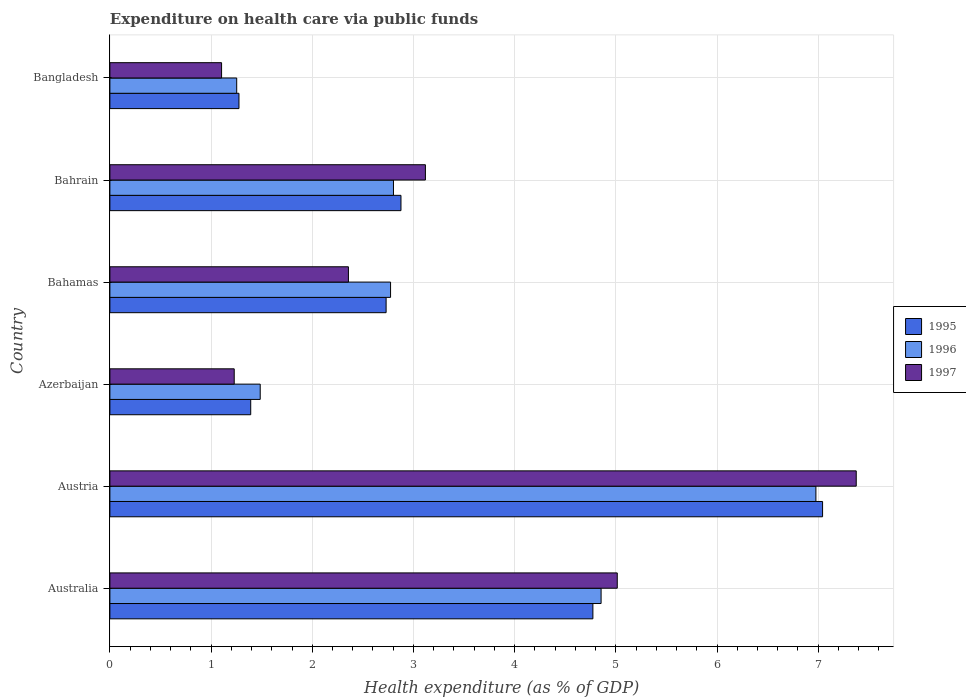How many different coloured bars are there?
Make the answer very short. 3. How many groups of bars are there?
Provide a succinct answer. 6. What is the label of the 1st group of bars from the top?
Provide a short and direct response. Bangladesh. What is the expenditure made on health care in 1995 in Azerbaijan?
Provide a succinct answer. 1.39. Across all countries, what is the maximum expenditure made on health care in 1997?
Make the answer very short. 7.38. Across all countries, what is the minimum expenditure made on health care in 1995?
Provide a short and direct response. 1.28. In which country was the expenditure made on health care in 1996 maximum?
Ensure brevity in your answer.  Austria. In which country was the expenditure made on health care in 1995 minimum?
Provide a succinct answer. Bangladesh. What is the total expenditure made on health care in 1997 in the graph?
Provide a succinct answer. 20.2. What is the difference between the expenditure made on health care in 1995 in Australia and that in Bahamas?
Your answer should be compact. 2.04. What is the difference between the expenditure made on health care in 1996 in Azerbaijan and the expenditure made on health care in 1995 in Australia?
Offer a very short reply. -3.29. What is the average expenditure made on health care in 1995 per country?
Offer a very short reply. 3.35. What is the difference between the expenditure made on health care in 1995 and expenditure made on health care in 1996 in Bahamas?
Make the answer very short. -0.04. In how many countries, is the expenditure made on health care in 1996 greater than 6 %?
Give a very brief answer. 1. What is the ratio of the expenditure made on health care in 1996 in Australia to that in Bangladesh?
Your response must be concise. 3.87. Is the expenditure made on health care in 1996 in Austria less than that in Bahrain?
Offer a very short reply. No. What is the difference between the highest and the second highest expenditure made on health care in 1997?
Your response must be concise. 2.36. What is the difference between the highest and the lowest expenditure made on health care in 1996?
Give a very brief answer. 5.72. In how many countries, is the expenditure made on health care in 1997 greater than the average expenditure made on health care in 1997 taken over all countries?
Your response must be concise. 2. How many bars are there?
Offer a terse response. 18. How many countries are there in the graph?
Offer a terse response. 6. What is the difference between two consecutive major ticks on the X-axis?
Keep it short and to the point. 1. Does the graph contain grids?
Offer a very short reply. Yes. Where does the legend appear in the graph?
Keep it short and to the point. Center right. What is the title of the graph?
Your answer should be very brief. Expenditure on health care via public funds. Does "1978" appear as one of the legend labels in the graph?
Offer a very short reply. No. What is the label or title of the X-axis?
Your answer should be very brief. Health expenditure (as % of GDP). What is the Health expenditure (as % of GDP) of 1995 in Australia?
Make the answer very short. 4.77. What is the Health expenditure (as % of GDP) in 1996 in Australia?
Your answer should be compact. 4.85. What is the Health expenditure (as % of GDP) in 1997 in Australia?
Your response must be concise. 5.01. What is the Health expenditure (as % of GDP) of 1995 in Austria?
Provide a short and direct response. 7.04. What is the Health expenditure (as % of GDP) in 1996 in Austria?
Offer a terse response. 6.98. What is the Health expenditure (as % of GDP) in 1997 in Austria?
Your answer should be very brief. 7.38. What is the Health expenditure (as % of GDP) in 1995 in Azerbaijan?
Your answer should be very brief. 1.39. What is the Health expenditure (as % of GDP) of 1996 in Azerbaijan?
Make the answer very short. 1.49. What is the Health expenditure (as % of GDP) of 1997 in Azerbaijan?
Your answer should be compact. 1.23. What is the Health expenditure (as % of GDP) in 1995 in Bahamas?
Offer a very short reply. 2.73. What is the Health expenditure (as % of GDP) in 1996 in Bahamas?
Keep it short and to the point. 2.77. What is the Health expenditure (as % of GDP) of 1997 in Bahamas?
Ensure brevity in your answer.  2.36. What is the Health expenditure (as % of GDP) of 1995 in Bahrain?
Your answer should be compact. 2.88. What is the Health expenditure (as % of GDP) of 1996 in Bahrain?
Ensure brevity in your answer.  2.8. What is the Health expenditure (as % of GDP) in 1997 in Bahrain?
Your answer should be compact. 3.12. What is the Health expenditure (as % of GDP) of 1995 in Bangladesh?
Give a very brief answer. 1.28. What is the Health expenditure (as % of GDP) of 1996 in Bangladesh?
Give a very brief answer. 1.25. What is the Health expenditure (as % of GDP) in 1997 in Bangladesh?
Offer a very short reply. 1.1. Across all countries, what is the maximum Health expenditure (as % of GDP) of 1995?
Provide a succinct answer. 7.04. Across all countries, what is the maximum Health expenditure (as % of GDP) in 1996?
Your answer should be compact. 6.98. Across all countries, what is the maximum Health expenditure (as % of GDP) in 1997?
Keep it short and to the point. 7.38. Across all countries, what is the minimum Health expenditure (as % of GDP) of 1995?
Offer a terse response. 1.28. Across all countries, what is the minimum Health expenditure (as % of GDP) of 1996?
Your response must be concise. 1.25. Across all countries, what is the minimum Health expenditure (as % of GDP) in 1997?
Ensure brevity in your answer.  1.1. What is the total Health expenditure (as % of GDP) of 1995 in the graph?
Your answer should be very brief. 20.09. What is the total Health expenditure (as % of GDP) in 1996 in the graph?
Provide a short and direct response. 20.15. What is the total Health expenditure (as % of GDP) in 1997 in the graph?
Offer a very short reply. 20.2. What is the difference between the Health expenditure (as % of GDP) in 1995 in Australia and that in Austria?
Make the answer very short. -2.27. What is the difference between the Health expenditure (as % of GDP) in 1996 in Australia and that in Austria?
Ensure brevity in your answer.  -2.12. What is the difference between the Health expenditure (as % of GDP) of 1997 in Australia and that in Austria?
Your response must be concise. -2.36. What is the difference between the Health expenditure (as % of GDP) of 1995 in Australia and that in Azerbaijan?
Provide a short and direct response. 3.38. What is the difference between the Health expenditure (as % of GDP) of 1996 in Australia and that in Azerbaijan?
Your answer should be compact. 3.37. What is the difference between the Health expenditure (as % of GDP) of 1997 in Australia and that in Azerbaijan?
Keep it short and to the point. 3.79. What is the difference between the Health expenditure (as % of GDP) of 1995 in Australia and that in Bahamas?
Give a very brief answer. 2.04. What is the difference between the Health expenditure (as % of GDP) in 1996 in Australia and that in Bahamas?
Your answer should be compact. 2.08. What is the difference between the Health expenditure (as % of GDP) of 1997 in Australia and that in Bahamas?
Provide a succinct answer. 2.66. What is the difference between the Health expenditure (as % of GDP) of 1995 in Australia and that in Bahrain?
Your answer should be compact. 1.9. What is the difference between the Health expenditure (as % of GDP) of 1996 in Australia and that in Bahrain?
Offer a very short reply. 2.05. What is the difference between the Health expenditure (as % of GDP) in 1997 in Australia and that in Bahrain?
Offer a very short reply. 1.9. What is the difference between the Health expenditure (as % of GDP) of 1995 in Australia and that in Bangladesh?
Offer a terse response. 3.5. What is the difference between the Health expenditure (as % of GDP) of 1996 in Australia and that in Bangladesh?
Offer a terse response. 3.6. What is the difference between the Health expenditure (as % of GDP) in 1997 in Australia and that in Bangladesh?
Your answer should be very brief. 3.91. What is the difference between the Health expenditure (as % of GDP) in 1995 in Austria and that in Azerbaijan?
Make the answer very short. 5.65. What is the difference between the Health expenditure (as % of GDP) in 1996 in Austria and that in Azerbaijan?
Your answer should be compact. 5.49. What is the difference between the Health expenditure (as % of GDP) in 1997 in Austria and that in Azerbaijan?
Offer a terse response. 6.15. What is the difference between the Health expenditure (as % of GDP) in 1995 in Austria and that in Bahamas?
Your response must be concise. 4.31. What is the difference between the Health expenditure (as % of GDP) of 1996 in Austria and that in Bahamas?
Provide a short and direct response. 4.2. What is the difference between the Health expenditure (as % of GDP) of 1997 in Austria and that in Bahamas?
Make the answer very short. 5.02. What is the difference between the Health expenditure (as % of GDP) of 1995 in Austria and that in Bahrain?
Your answer should be very brief. 4.17. What is the difference between the Health expenditure (as % of GDP) of 1996 in Austria and that in Bahrain?
Keep it short and to the point. 4.17. What is the difference between the Health expenditure (as % of GDP) in 1997 in Austria and that in Bahrain?
Your answer should be compact. 4.26. What is the difference between the Health expenditure (as % of GDP) in 1995 in Austria and that in Bangladesh?
Your answer should be compact. 5.77. What is the difference between the Health expenditure (as % of GDP) of 1996 in Austria and that in Bangladesh?
Offer a terse response. 5.72. What is the difference between the Health expenditure (as % of GDP) in 1997 in Austria and that in Bangladesh?
Provide a short and direct response. 6.27. What is the difference between the Health expenditure (as % of GDP) of 1995 in Azerbaijan and that in Bahamas?
Provide a short and direct response. -1.34. What is the difference between the Health expenditure (as % of GDP) of 1996 in Azerbaijan and that in Bahamas?
Ensure brevity in your answer.  -1.29. What is the difference between the Health expenditure (as % of GDP) in 1997 in Azerbaijan and that in Bahamas?
Offer a very short reply. -1.13. What is the difference between the Health expenditure (as % of GDP) of 1995 in Azerbaijan and that in Bahrain?
Your answer should be compact. -1.48. What is the difference between the Health expenditure (as % of GDP) of 1996 in Azerbaijan and that in Bahrain?
Provide a short and direct response. -1.32. What is the difference between the Health expenditure (as % of GDP) of 1997 in Azerbaijan and that in Bahrain?
Give a very brief answer. -1.89. What is the difference between the Health expenditure (as % of GDP) of 1995 in Azerbaijan and that in Bangladesh?
Your answer should be compact. 0.12. What is the difference between the Health expenditure (as % of GDP) in 1996 in Azerbaijan and that in Bangladesh?
Your response must be concise. 0.23. What is the difference between the Health expenditure (as % of GDP) of 1997 in Azerbaijan and that in Bangladesh?
Your answer should be very brief. 0.12. What is the difference between the Health expenditure (as % of GDP) in 1995 in Bahamas and that in Bahrain?
Keep it short and to the point. -0.15. What is the difference between the Health expenditure (as % of GDP) in 1996 in Bahamas and that in Bahrain?
Keep it short and to the point. -0.03. What is the difference between the Health expenditure (as % of GDP) in 1997 in Bahamas and that in Bahrain?
Ensure brevity in your answer.  -0.76. What is the difference between the Health expenditure (as % of GDP) of 1995 in Bahamas and that in Bangladesh?
Your answer should be very brief. 1.45. What is the difference between the Health expenditure (as % of GDP) in 1996 in Bahamas and that in Bangladesh?
Keep it short and to the point. 1.52. What is the difference between the Health expenditure (as % of GDP) in 1997 in Bahamas and that in Bangladesh?
Keep it short and to the point. 1.25. What is the difference between the Health expenditure (as % of GDP) in 1995 in Bahrain and that in Bangladesh?
Offer a very short reply. 1.6. What is the difference between the Health expenditure (as % of GDP) of 1996 in Bahrain and that in Bangladesh?
Your response must be concise. 1.55. What is the difference between the Health expenditure (as % of GDP) in 1997 in Bahrain and that in Bangladesh?
Provide a short and direct response. 2.01. What is the difference between the Health expenditure (as % of GDP) of 1995 in Australia and the Health expenditure (as % of GDP) of 1996 in Austria?
Your answer should be compact. -2.2. What is the difference between the Health expenditure (as % of GDP) in 1995 in Australia and the Health expenditure (as % of GDP) in 1997 in Austria?
Your answer should be compact. -2.6. What is the difference between the Health expenditure (as % of GDP) in 1996 in Australia and the Health expenditure (as % of GDP) in 1997 in Austria?
Your response must be concise. -2.52. What is the difference between the Health expenditure (as % of GDP) in 1995 in Australia and the Health expenditure (as % of GDP) in 1996 in Azerbaijan?
Your answer should be compact. 3.29. What is the difference between the Health expenditure (as % of GDP) of 1995 in Australia and the Health expenditure (as % of GDP) of 1997 in Azerbaijan?
Offer a very short reply. 3.54. What is the difference between the Health expenditure (as % of GDP) of 1996 in Australia and the Health expenditure (as % of GDP) of 1997 in Azerbaijan?
Your answer should be very brief. 3.63. What is the difference between the Health expenditure (as % of GDP) in 1995 in Australia and the Health expenditure (as % of GDP) in 1996 in Bahamas?
Your answer should be compact. 2. What is the difference between the Health expenditure (as % of GDP) in 1995 in Australia and the Health expenditure (as % of GDP) in 1997 in Bahamas?
Provide a short and direct response. 2.42. What is the difference between the Health expenditure (as % of GDP) in 1996 in Australia and the Health expenditure (as % of GDP) in 1997 in Bahamas?
Your answer should be very brief. 2.5. What is the difference between the Health expenditure (as % of GDP) of 1995 in Australia and the Health expenditure (as % of GDP) of 1996 in Bahrain?
Offer a terse response. 1.97. What is the difference between the Health expenditure (as % of GDP) of 1995 in Australia and the Health expenditure (as % of GDP) of 1997 in Bahrain?
Give a very brief answer. 1.66. What is the difference between the Health expenditure (as % of GDP) in 1996 in Australia and the Health expenditure (as % of GDP) in 1997 in Bahrain?
Offer a very short reply. 1.74. What is the difference between the Health expenditure (as % of GDP) of 1995 in Australia and the Health expenditure (as % of GDP) of 1996 in Bangladesh?
Give a very brief answer. 3.52. What is the difference between the Health expenditure (as % of GDP) in 1995 in Australia and the Health expenditure (as % of GDP) in 1997 in Bangladesh?
Offer a terse response. 3.67. What is the difference between the Health expenditure (as % of GDP) in 1996 in Australia and the Health expenditure (as % of GDP) in 1997 in Bangladesh?
Give a very brief answer. 3.75. What is the difference between the Health expenditure (as % of GDP) in 1995 in Austria and the Health expenditure (as % of GDP) in 1996 in Azerbaijan?
Your answer should be compact. 5.56. What is the difference between the Health expenditure (as % of GDP) in 1995 in Austria and the Health expenditure (as % of GDP) in 1997 in Azerbaijan?
Ensure brevity in your answer.  5.81. What is the difference between the Health expenditure (as % of GDP) of 1996 in Austria and the Health expenditure (as % of GDP) of 1997 in Azerbaijan?
Offer a terse response. 5.75. What is the difference between the Health expenditure (as % of GDP) of 1995 in Austria and the Health expenditure (as % of GDP) of 1996 in Bahamas?
Offer a terse response. 4.27. What is the difference between the Health expenditure (as % of GDP) in 1995 in Austria and the Health expenditure (as % of GDP) in 1997 in Bahamas?
Ensure brevity in your answer.  4.69. What is the difference between the Health expenditure (as % of GDP) of 1996 in Austria and the Health expenditure (as % of GDP) of 1997 in Bahamas?
Make the answer very short. 4.62. What is the difference between the Health expenditure (as % of GDP) of 1995 in Austria and the Health expenditure (as % of GDP) of 1996 in Bahrain?
Give a very brief answer. 4.24. What is the difference between the Health expenditure (as % of GDP) of 1995 in Austria and the Health expenditure (as % of GDP) of 1997 in Bahrain?
Your answer should be very brief. 3.93. What is the difference between the Health expenditure (as % of GDP) in 1996 in Austria and the Health expenditure (as % of GDP) in 1997 in Bahrain?
Your answer should be compact. 3.86. What is the difference between the Health expenditure (as % of GDP) of 1995 in Austria and the Health expenditure (as % of GDP) of 1996 in Bangladesh?
Keep it short and to the point. 5.79. What is the difference between the Health expenditure (as % of GDP) of 1995 in Austria and the Health expenditure (as % of GDP) of 1997 in Bangladesh?
Make the answer very short. 5.94. What is the difference between the Health expenditure (as % of GDP) in 1996 in Austria and the Health expenditure (as % of GDP) in 1997 in Bangladesh?
Ensure brevity in your answer.  5.87. What is the difference between the Health expenditure (as % of GDP) of 1995 in Azerbaijan and the Health expenditure (as % of GDP) of 1996 in Bahamas?
Provide a short and direct response. -1.38. What is the difference between the Health expenditure (as % of GDP) of 1995 in Azerbaijan and the Health expenditure (as % of GDP) of 1997 in Bahamas?
Provide a short and direct response. -0.97. What is the difference between the Health expenditure (as % of GDP) of 1996 in Azerbaijan and the Health expenditure (as % of GDP) of 1997 in Bahamas?
Make the answer very short. -0.87. What is the difference between the Health expenditure (as % of GDP) of 1995 in Azerbaijan and the Health expenditure (as % of GDP) of 1996 in Bahrain?
Provide a succinct answer. -1.41. What is the difference between the Health expenditure (as % of GDP) in 1995 in Azerbaijan and the Health expenditure (as % of GDP) in 1997 in Bahrain?
Your answer should be compact. -1.73. What is the difference between the Health expenditure (as % of GDP) in 1996 in Azerbaijan and the Health expenditure (as % of GDP) in 1997 in Bahrain?
Your response must be concise. -1.63. What is the difference between the Health expenditure (as % of GDP) of 1995 in Azerbaijan and the Health expenditure (as % of GDP) of 1996 in Bangladesh?
Provide a short and direct response. 0.14. What is the difference between the Health expenditure (as % of GDP) in 1995 in Azerbaijan and the Health expenditure (as % of GDP) in 1997 in Bangladesh?
Your answer should be compact. 0.29. What is the difference between the Health expenditure (as % of GDP) of 1996 in Azerbaijan and the Health expenditure (as % of GDP) of 1997 in Bangladesh?
Your answer should be very brief. 0.38. What is the difference between the Health expenditure (as % of GDP) in 1995 in Bahamas and the Health expenditure (as % of GDP) in 1996 in Bahrain?
Ensure brevity in your answer.  -0.07. What is the difference between the Health expenditure (as % of GDP) in 1995 in Bahamas and the Health expenditure (as % of GDP) in 1997 in Bahrain?
Ensure brevity in your answer.  -0.39. What is the difference between the Health expenditure (as % of GDP) of 1996 in Bahamas and the Health expenditure (as % of GDP) of 1997 in Bahrain?
Give a very brief answer. -0.34. What is the difference between the Health expenditure (as % of GDP) in 1995 in Bahamas and the Health expenditure (as % of GDP) in 1996 in Bangladesh?
Offer a very short reply. 1.48. What is the difference between the Health expenditure (as % of GDP) in 1995 in Bahamas and the Health expenditure (as % of GDP) in 1997 in Bangladesh?
Provide a short and direct response. 1.63. What is the difference between the Health expenditure (as % of GDP) of 1996 in Bahamas and the Health expenditure (as % of GDP) of 1997 in Bangladesh?
Provide a short and direct response. 1.67. What is the difference between the Health expenditure (as % of GDP) in 1995 in Bahrain and the Health expenditure (as % of GDP) in 1996 in Bangladesh?
Give a very brief answer. 1.62. What is the difference between the Health expenditure (as % of GDP) of 1995 in Bahrain and the Health expenditure (as % of GDP) of 1997 in Bangladesh?
Your answer should be very brief. 1.77. What is the difference between the Health expenditure (as % of GDP) in 1996 in Bahrain and the Health expenditure (as % of GDP) in 1997 in Bangladesh?
Your answer should be compact. 1.7. What is the average Health expenditure (as % of GDP) of 1995 per country?
Provide a succinct answer. 3.35. What is the average Health expenditure (as % of GDP) in 1996 per country?
Give a very brief answer. 3.36. What is the average Health expenditure (as % of GDP) of 1997 per country?
Keep it short and to the point. 3.37. What is the difference between the Health expenditure (as % of GDP) of 1995 and Health expenditure (as % of GDP) of 1996 in Australia?
Keep it short and to the point. -0.08. What is the difference between the Health expenditure (as % of GDP) in 1995 and Health expenditure (as % of GDP) in 1997 in Australia?
Provide a short and direct response. -0.24. What is the difference between the Health expenditure (as % of GDP) of 1996 and Health expenditure (as % of GDP) of 1997 in Australia?
Your answer should be compact. -0.16. What is the difference between the Health expenditure (as % of GDP) of 1995 and Health expenditure (as % of GDP) of 1996 in Austria?
Provide a short and direct response. 0.07. What is the difference between the Health expenditure (as % of GDP) in 1995 and Health expenditure (as % of GDP) in 1997 in Austria?
Provide a short and direct response. -0.33. What is the difference between the Health expenditure (as % of GDP) of 1996 and Health expenditure (as % of GDP) of 1997 in Austria?
Offer a terse response. -0.4. What is the difference between the Health expenditure (as % of GDP) in 1995 and Health expenditure (as % of GDP) in 1996 in Azerbaijan?
Provide a succinct answer. -0.09. What is the difference between the Health expenditure (as % of GDP) in 1995 and Health expenditure (as % of GDP) in 1997 in Azerbaijan?
Your answer should be very brief. 0.16. What is the difference between the Health expenditure (as % of GDP) in 1996 and Health expenditure (as % of GDP) in 1997 in Azerbaijan?
Your response must be concise. 0.26. What is the difference between the Health expenditure (as % of GDP) in 1995 and Health expenditure (as % of GDP) in 1996 in Bahamas?
Offer a very short reply. -0.04. What is the difference between the Health expenditure (as % of GDP) in 1995 and Health expenditure (as % of GDP) in 1997 in Bahamas?
Keep it short and to the point. 0.37. What is the difference between the Health expenditure (as % of GDP) in 1996 and Health expenditure (as % of GDP) in 1997 in Bahamas?
Give a very brief answer. 0.42. What is the difference between the Health expenditure (as % of GDP) in 1995 and Health expenditure (as % of GDP) in 1996 in Bahrain?
Provide a short and direct response. 0.07. What is the difference between the Health expenditure (as % of GDP) in 1995 and Health expenditure (as % of GDP) in 1997 in Bahrain?
Provide a succinct answer. -0.24. What is the difference between the Health expenditure (as % of GDP) of 1996 and Health expenditure (as % of GDP) of 1997 in Bahrain?
Your response must be concise. -0.32. What is the difference between the Health expenditure (as % of GDP) of 1995 and Health expenditure (as % of GDP) of 1996 in Bangladesh?
Ensure brevity in your answer.  0.02. What is the difference between the Health expenditure (as % of GDP) of 1995 and Health expenditure (as % of GDP) of 1997 in Bangladesh?
Give a very brief answer. 0.17. What is the difference between the Health expenditure (as % of GDP) of 1996 and Health expenditure (as % of GDP) of 1997 in Bangladesh?
Make the answer very short. 0.15. What is the ratio of the Health expenditure (as % of GDP) of 1995 in Australia to that in Austria?
Provide a short and direct response. 0.68. What is the ratio of the Health expenditure (as % of GDP) in 1996 in Australia to that in Austria?
Your response must be concise. 0.7. What is the ratio of the Health expenditure (as % of GDP) of 1997 in Australia to that in Austria?
Ensure brevity in your answer.  0.68. What is the ratio of the Health expenditure (as % of GDP) in 1995 in Australia to that in Azerbaijan?
Give a very brief answer. 3.43. What is the ratio of the Health expenditure (as % of GDP) in 1996 in Australia to that in Azerbaijan?
Your response must be concise. 3.27. What is the ratio of the Health expenditure (as % of GDP) in 1997 in Australia to that in Azerbaijan?
Give a very brief answer. 4.08. What is the ratio of the Health expenditure (as % of GDP) in 1995 in Australia to that in Bahamas?
Provide a succinct answer. 1.75. What is the ratio of the Health expenditure (as % of GDP) in 1996 in Australia to that in Bahamas?
Offer a terse response. 1.75. What is the ratio of the Health expenditure (as % of GDP) in 1997 in Australia to that in Bahamas?
Your answer should be compact. 2.13. What is the ratio of the Health expenditure (as % of GDP) in 1995 in Australia to that in Bahrain?
Your answer should be very brief. 1.66. What is the ratio of the Health expenditure (as % of GDP) of 1996 in Australia to that in Bahrain?
Your response must be concise. 1.73. What is the ratio of the Health expenditure (as % of GDP) in 1997 in Australia to that in Bahrain?
Offer a very short reply. 1.61. What is the ratio of the Health expenditure (as % of GDP) in 1995 in Australia to that in Bangladesh?
Offer a very short reply. 3.74. What is the ratio of the Health expenditure (as % of GDP) in 1996 in Australia to that in Bangladesh?
Keep it short and to the point. 3.87. What is the ratio of the Health expenditure (as % of GDP) of 1997 in Australia to that in Bangladesh?
Offer a terse response. 4.54. What is the ratio of the Health expenditure (as % of GDP) of 1995 in Austria to that in Azerbaijan?
Provide a short and direct response. 5.06. What is the ratio of the Health expenditure (as % of GDP) of 1996 in Austria to that in Azerbaijan?
Give a very brief answer. 4.7. What is the ratio of the Health expenditure (as % of GDP) of 1997 in Austria to that in Azerbaijan?
Give a very brief answer. 6. What is the ratio of the Health expenditure (as % of GDP) of 1995 in Austria to that in Bahamas?
Ensure brevity in your answer.  2.58. What is the ratio of the Health expenditure (as % of GDP) of 1996 in Austria to that in Bahamas?
Your answer should be compact. 2.52. What is the ratio of the Health expenditure (as % of GDP) of 1997 in Austria to that in Bahamas?
Offer a very short reply. 3.13. What is the ratio of the Health expenditure (as % of GDP) in 1995 in Austria to that in Bahrain?
Your answer should be compact. 2.45. What is the ratio of the Health expenditure (as % of GDP) in 1996 in Austria to that in Bahrain?
Ensure brevity in your answer.  2.49. What is the ratio of the Health expenditure (as % of GDP) in 1997 in Austria to that in Bahrain?
Offer a very short reply. 2.37. What is the ratio of the Health expenditure (as % of GDP) of 1995 in Austria to that in Bangladesh?
Offer a very short reply. 5.52. What is the ratio of the Health expenditure (as % of GDP) in 1996 in Austria to that in Bangladesh?
Your answer should be compact. 5.57. What is the ratio of the Health expenditure (as % of GDP) of 1997 in Austria to that in Bangladesh?
Offer a terse response. 6.68. What is the ratio of the Health expenditure (as % of GDP) in 1995 in Azerbaijan to that in Bahamas?
Provide a succinct answer. 0.51. What is the ratio of the Health expenditure (as % of GDP) of 1996 in Azerbaijan to that in Bahamas?
Make the answer very short. 0.54. What is the ratio of the Health expenditure (as % of GDP) of 1997 in Azerbaijan to that in Bahamas?
Your answer should be compact. 0.52. What is the ratio of the Health expenditure (as % of GDP) of 1995 in Azerbaijan to that in Bahrain?
Keep it short and to the point. 0.48. What is the ratio of the Health expenditure (as % of GDP) of 1996 in Azerbaijan to that in Bahrain?
Your answer should be very brief. 0.53. What is the ratio of the Health expenditure (as % of GDP) of 1997 in Azerbaijan to that in Bahrain?
Ensure brevity in your answer.  0.39. What is the ratio of the Health expenditure (as % of GDP) of 1995 in Azerbaijan to that in Bangladesh?
Give a very brief answer. 1.09. What is the ratio of the Health expenditure (as % of GDP) of 1996 in Azerbaijan to that in Bangladesh?
Offer a terse response. 1.19. What is the ratio of the Health expenditure (as % of GDP) of 1997 in Azerbaijan to that in Bangladesh?
Give a very brief answer. 1.11. What is the ratio of the Health expenditure (as % of GDP) in 1995 in Bahamas to that in Bahrain?
Offer a very short reply. 0.95. What is the ratio of the Health expenditure (as % of GDP) of 1997 in Bahamas to that in Bahrain?
Provide a short and direct response. 0.76. What is the ratio of the Health expenditure (as % of GDP) of 1995 in Bahamas to that in Bangladesh?
Your answer should be very brief. 2.14. What is the ratio of the Health expenditure (as % of GDP) of 1996 in Bahamas to that in Bangladesh?
Offer a terse response. 2.21. What is the ratio of the Health expenditure (as % of GDP) in 1997 in Bahamas to that in Bangladesh?
Your answer should be very brief. 2.14. What is the ratio of the Health expenditure (as % of GDP) of 1995 in Bahrain to that in Bangladesh?
Offer a terse response. 2.25. What is the ratio of the Health expenditure (as % of GDP) of 1996 in Bahrain to that in Bangladesh?
Ensure brevity in your answer.  2.24. What is the ratio of the Health expenditure (as % of GDP) of 1997 in Bahrain to that in Bangladesh?
Ensure brevity in your answer.  2.83. What is the difference between the highest and the second highest Health expenditure (as % of GDP) of 1995?
Provide a short and direct response. 2.27. What is the difference between the highest and the second highest Health expenditure (as % of GDP) of 1996?
Ensure brevity in your answer.  2.12. What is the difference between the highest and the second highest Health expenditure (as % of GDP) in 1997?
Ensure brevity in your answer.  2.36. What is the difference between the highest and the lowest Health expenditure (as % of GDP) of 1995?
Provide a short and direct response. 5.77. What is the difference between the highest and the lowest Health expenditure (as % of GDP) in 1996?
Offer a very short reply. 5.72. What is the difference between the highest and the lowest Health expenditure (as % of GDP) in 1997?
Your answer should be compact. 6.27. 